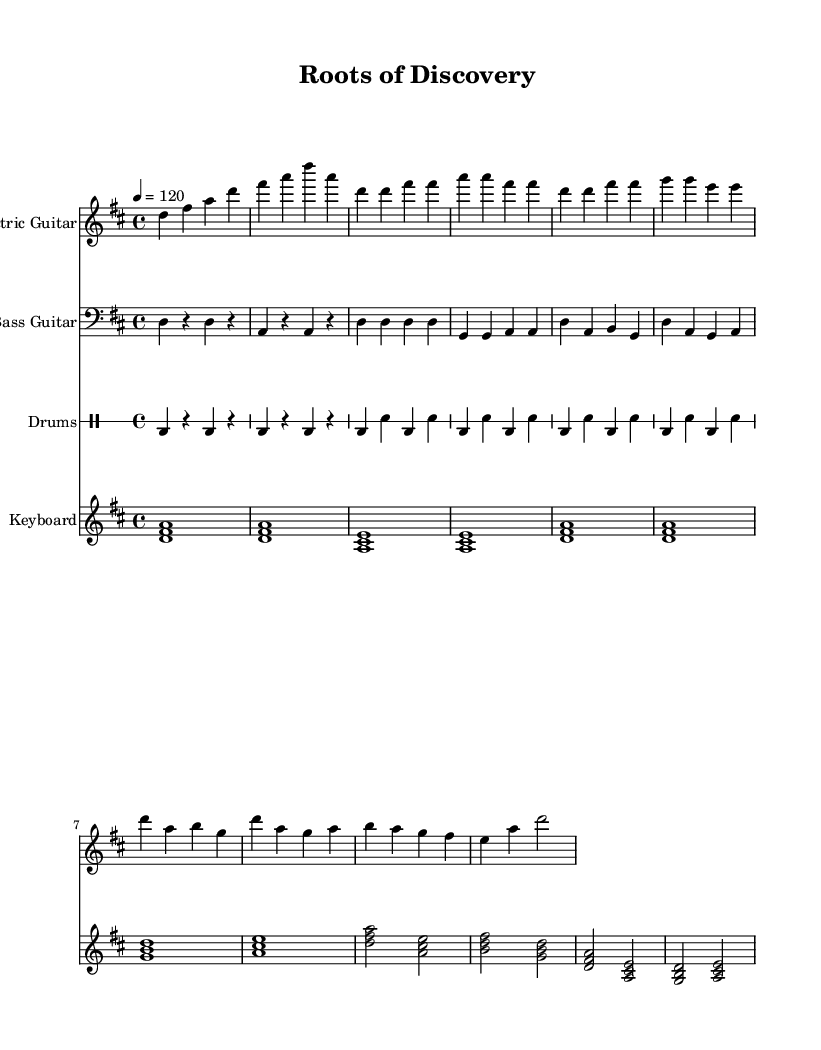What is the key signature of this music? The key signature is indicated on the staff at the beginning of the piece. Here, it shows two sharps, which correspond to F# and C#.
Answer: D major What is the time signature of this music? The time signature appears at the beginning of the piece, represented as a fraction. Here, it shows four beats per measure, written as 4/4.
Answer: 4/4 What is the tempo marking for this piece? The tempo is specified above the staff as a number followed by "=," indicating the number of beats per minute. In this case, it is marked as 120 beats per minute.
Answer: 120 How many measures are in the introduction section? By examining the introductory section, we can count the measures. The intro consists of four measures of music.
Answer: 4 What is the primary instrument featured in the melody? The instrument playing the melody is often identified at the beginning of the staff by its name, which in this case is the "Electric Guitar." This is the lead role in the piece.
Answer: Electric Guitar What chords are used in the verse section? By analyzing the notes written in the verse, we can identify the chords. The verse section features the chords D, G, and A throughout its measures.
Answer: D, G, A How many different instruments are present in this score? By counting the distinct staves in the score, we observe that there are four instruments represented: Electric Guitar, Bass Guitar, Drums, and Keyboard.
Answer: 4 